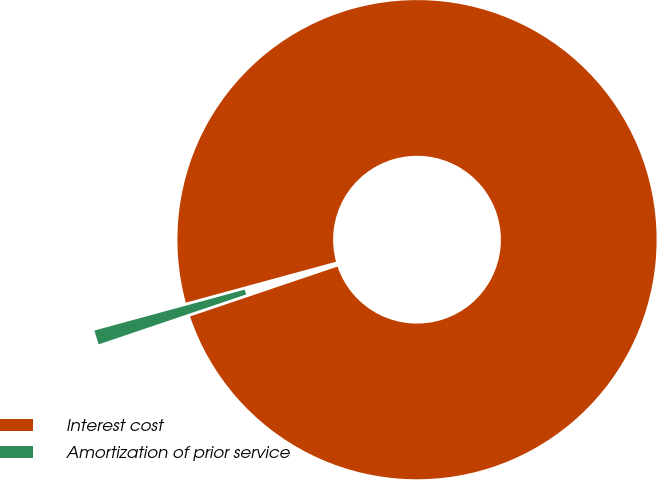Convert chart. <chart><loc_0><loc_0><loc_500><loc_500><pie_chart><fcel>Interest cost<fcel>Amortization of prior service<nl><fcel>99.04%<fcel>0.96%<nl></chart> 